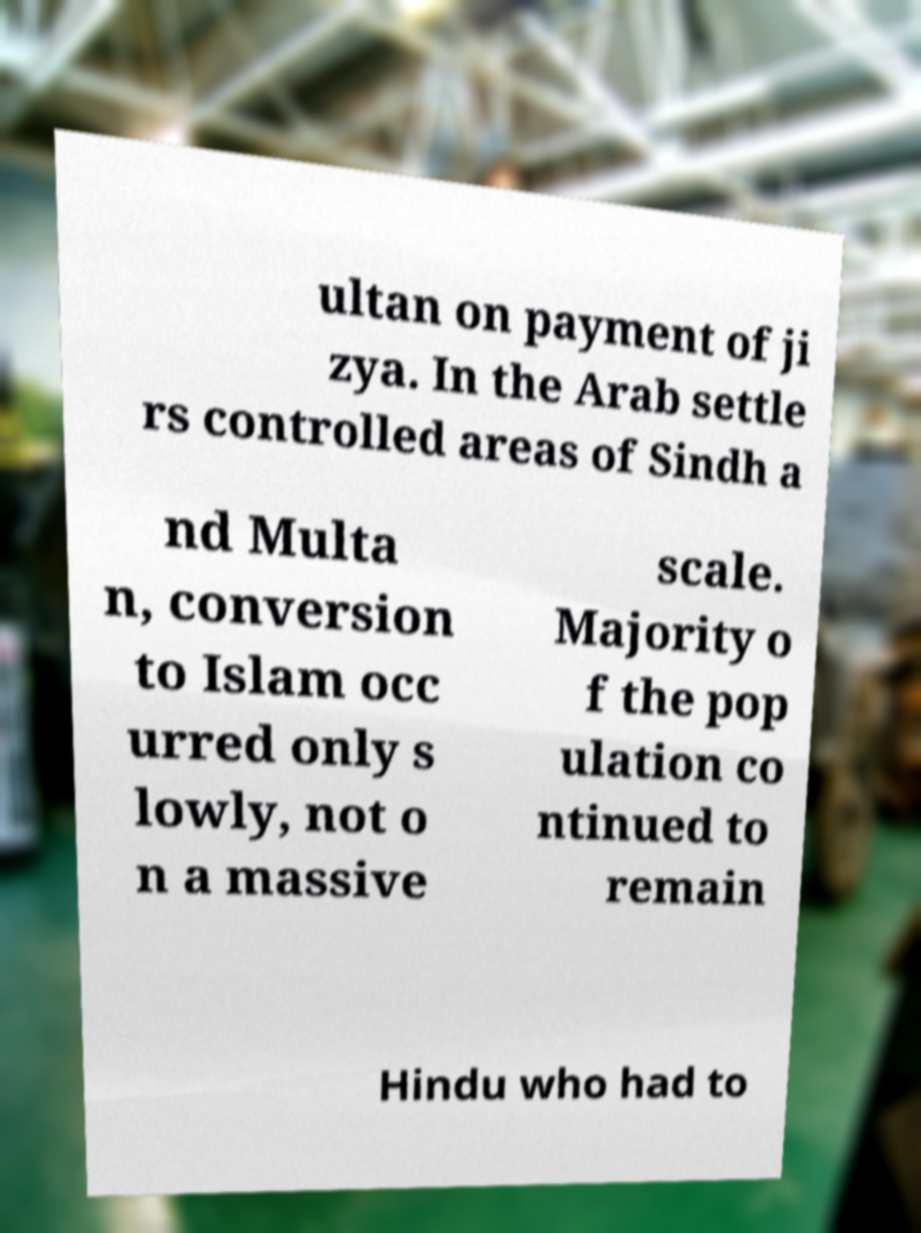Could you assist in decoding the text presented in this image and type it out clearly? ultan on payment of ji zya. In the Arab settle rs controlled areas of Sindh a nd Multa n, conversion to Islam occ urred only s lowly, not o n a massive scale. Majority o f the pop ulation co ntinued to remain Hindu who had to 